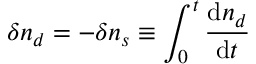<formula> <loc_0><loc_0><loc_500><loc_500>\delta n _ { d } = - \delta n _ { s } \equiv \int _ { 0 } ^ { t } \frac { d n _ { d } } { d t }</formula> 